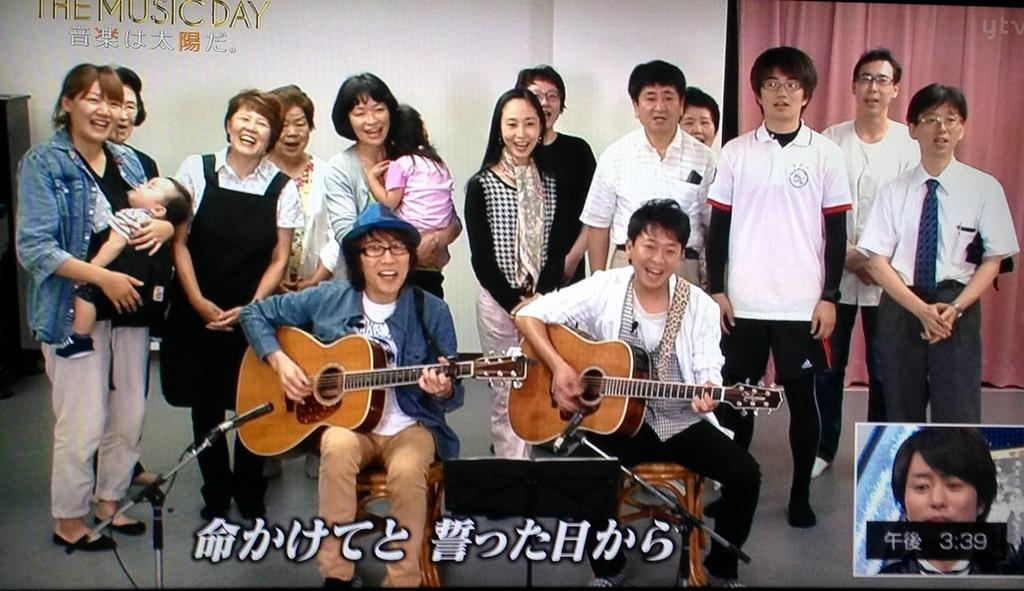How many people are in the image? There are two persons in the image. What are the two persons doing in the image? The two persons are sitting on a chair and playing a guitar. Can you describe the people in the background of the image? There are people in the background of the image, and they are standing and smiling. What type of cow can be seen grazing in the background of the image? There is no cow present in the image; it features two persons playing a guitar and people in the background standing and smiling. 